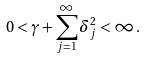<formula> <loc_0><loc_0><loc_500><loc_500>0 < \gamma + \sum _ { j = 1 } ^ { \infty } \delta _ { j } ^ { 2 } < \infty \, .</formula> 